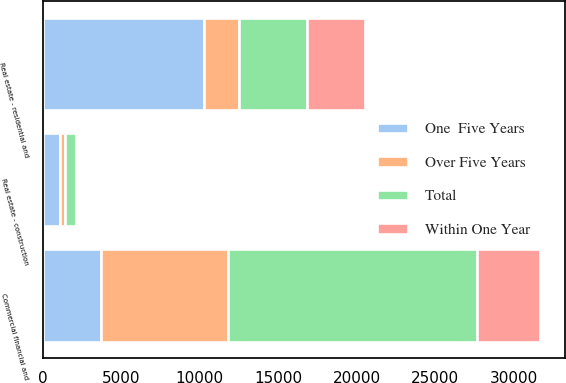<chart> <loc_0><loc_0><loc_500><loc_500><stacked_bar_chart><ecel><fcel>Commercial financial and<fcel>Real estate - construction<fcel>Real estate - residential and<nl><fcel>Over Five Years<fcel>8145<fcel>321<fcel>2247<nl><fcel>Total<fcel>15807<fcel>688<fcel>4332<nl><fcel>Within One Year<fcel>4030<fcel>91<fcel>3693<nl><fcel>One  Five Years<fcel>3693<fcel>1100<fcel>10272<nl></chart> 